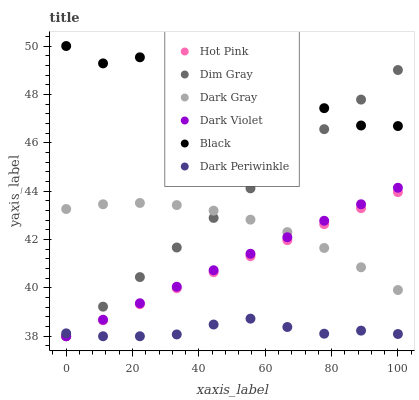Does Dark Periwinkle have the minimum area under the curve?
Answer yes or no. Yes. Does Black have the maximum area under the curve?
Answer yes or no. Yes. Does Hot Pink have the minimum area under the curve?
Answer yes or no. No. Does Hot Pink have the maximum area under the curve?
Answer yes or no. No. Is Hot Pink the smoothest?
Answer yes or no. Yes. Is Black the roughest?
Answer yes or no. Yes. Is Dark Violet the smoothest?
Answer yes or no. No. Is Dark Violet the roughest?
Answer yes or no. No. Does Dim Gray have the lowest value?
Answer yes or no. Yes. Does Dark Gray have the lowest value?
Answer yes or no. No. Does Black have the highest value?
Answer yes or no. Yes. Does Hot Pink have the highest value?
Answer yes or no. No. Is Dark Periwinkle less than Black?
Answer yes or no. Yes. Is Dark Gray greater than Dark Periwinkle?
Answer yes or no. Yes. Does Dim Gray intersect Dark Periwinkle?
Answer yes or no. Yes. Is Dim Gray less than Dark Periwinkle?
Answer yes or no. No. Is Dim Gray greater than Dark Periwinkle?
Answer yes or no. No. Does Dark Periwinkle intersect Black?
Answer yes or no. No. 